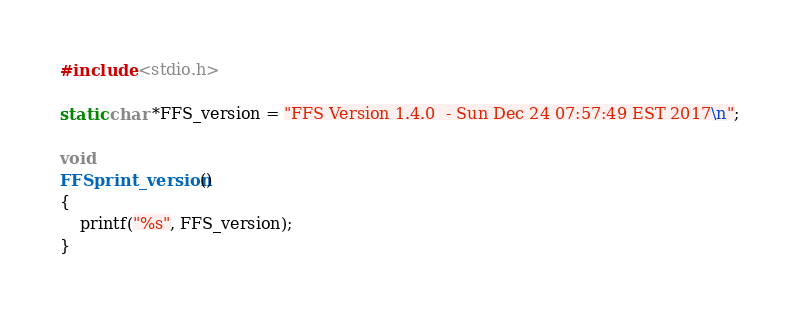<code> <loc_0><loc_0><loc_500><loc_500><_C_>#include <stdio.h>

static char *FFS_version = "FFS Version 1.4.0  - Sun Dec 24 07:57:49 EST 2017\n";

void
FFSprint_version()
{
    printf("%s", FFS_version);
}

</code> 